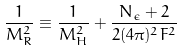Convert formula to latex. <formula><loc_0><loc_0><loc_500><loc_500>\frac { 1 } { M _ { R } ^ { 2 } } \equiv \frac { 1 } { M _ { H } ^ { 2 } } + \frac { N _ { \epsilon } + 2 } { 2 ( 4 \pi ) ^ { 2 } F ^ { 2 } }</formula> 